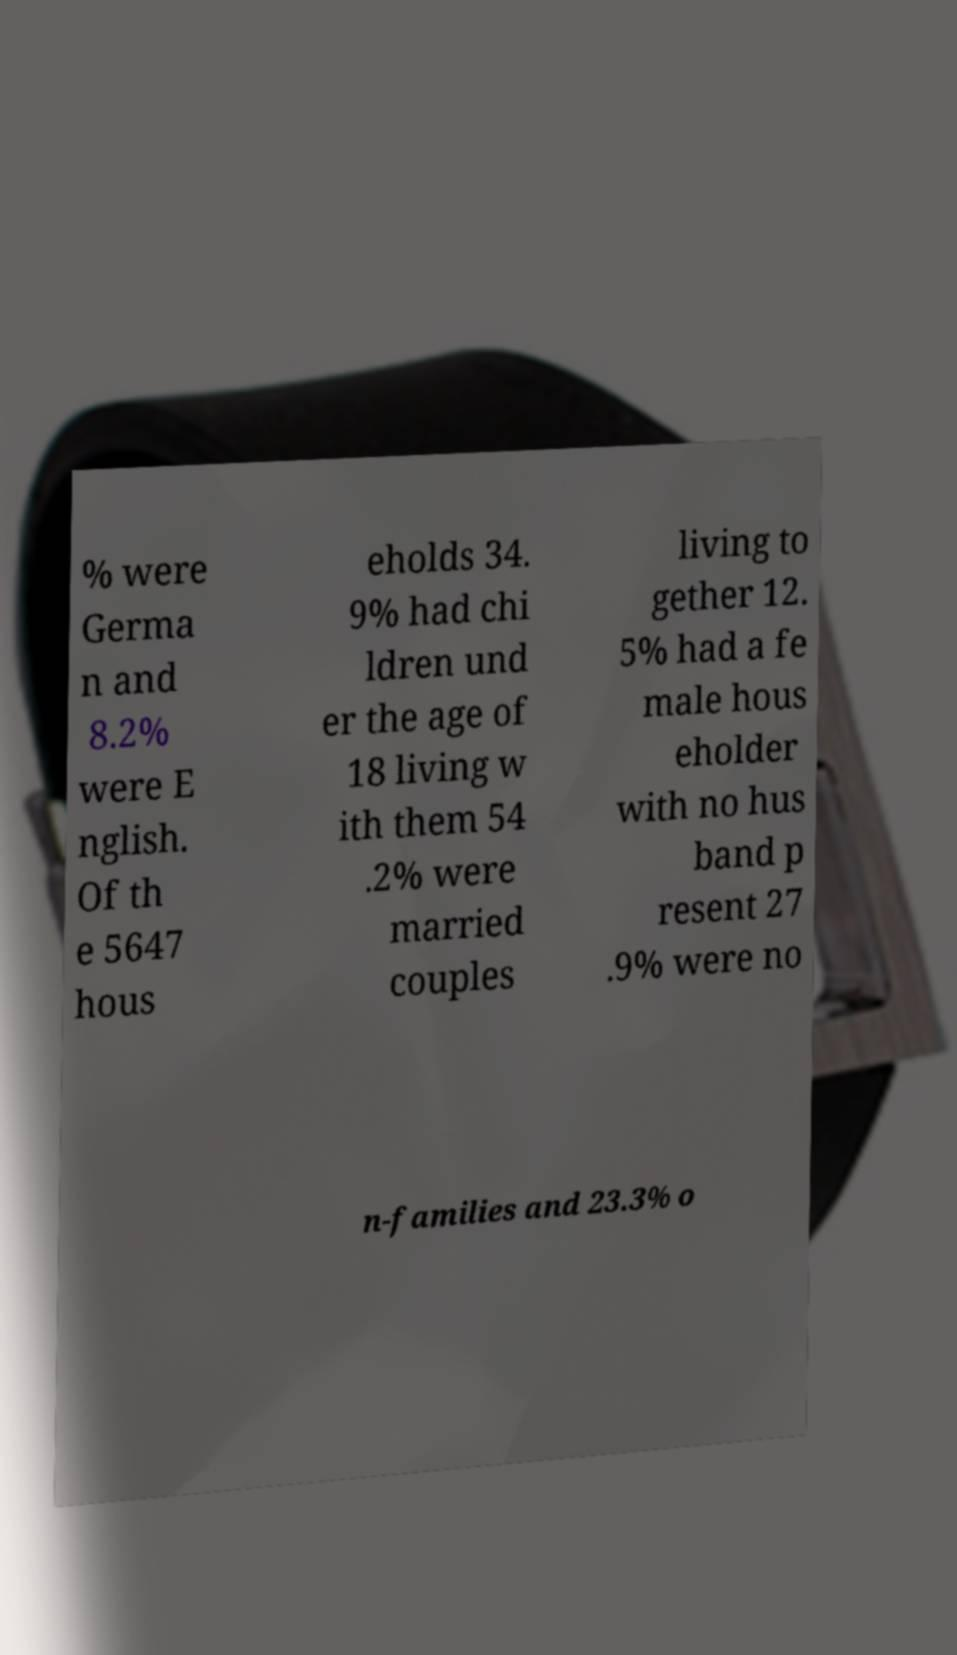Please read and relay the text visible in this image. What does it say? % were Germa n and 8.2% were E nglish. Of th e 5647 hous eholds 34. 9% had chi ldren und er the age of 18 living w ith them 54 .2% were married couples living to gether 12. 5% had a fe male hous eholder with no hus band p resent 27 .9% were no n-families and 23.3% o 